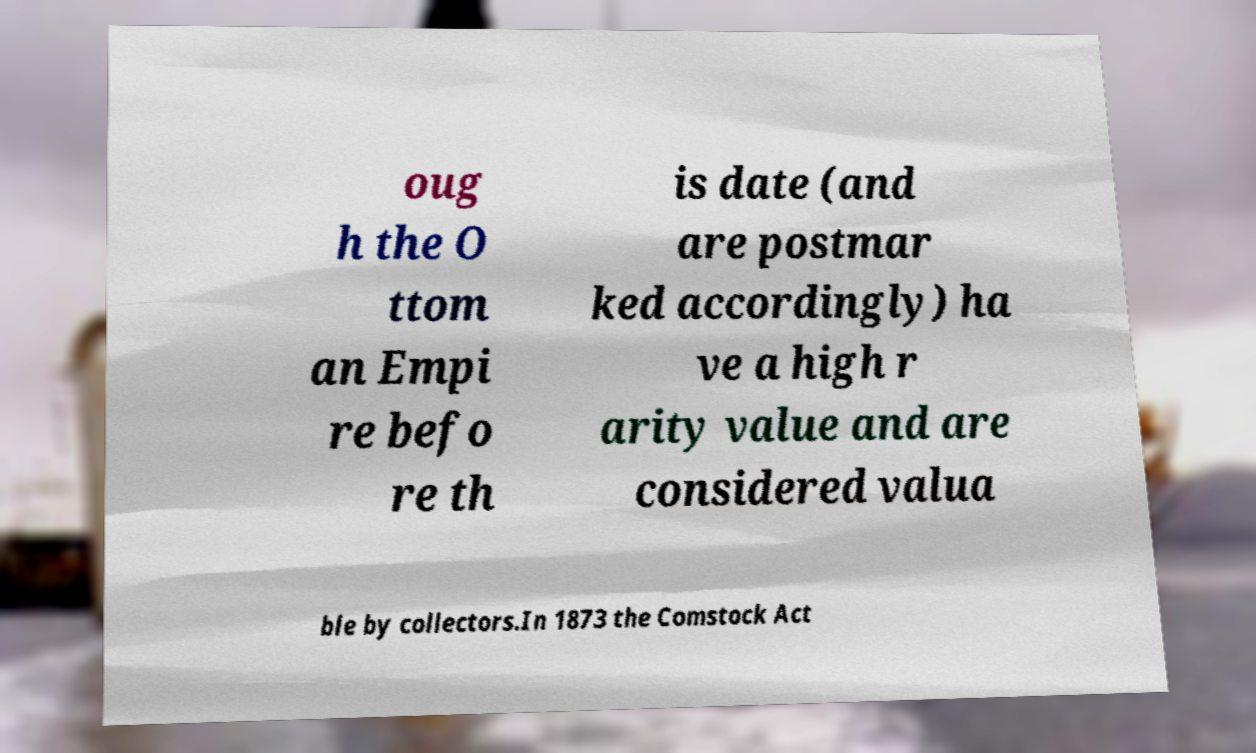Please identify and transcribe the text found in this image. oug h the O ttom an Empi re befo re th is date (and are postmar ked accordingly) ha ve a high r arity value and are considered valua ble by collectors.In 1873 the Comstock Act 